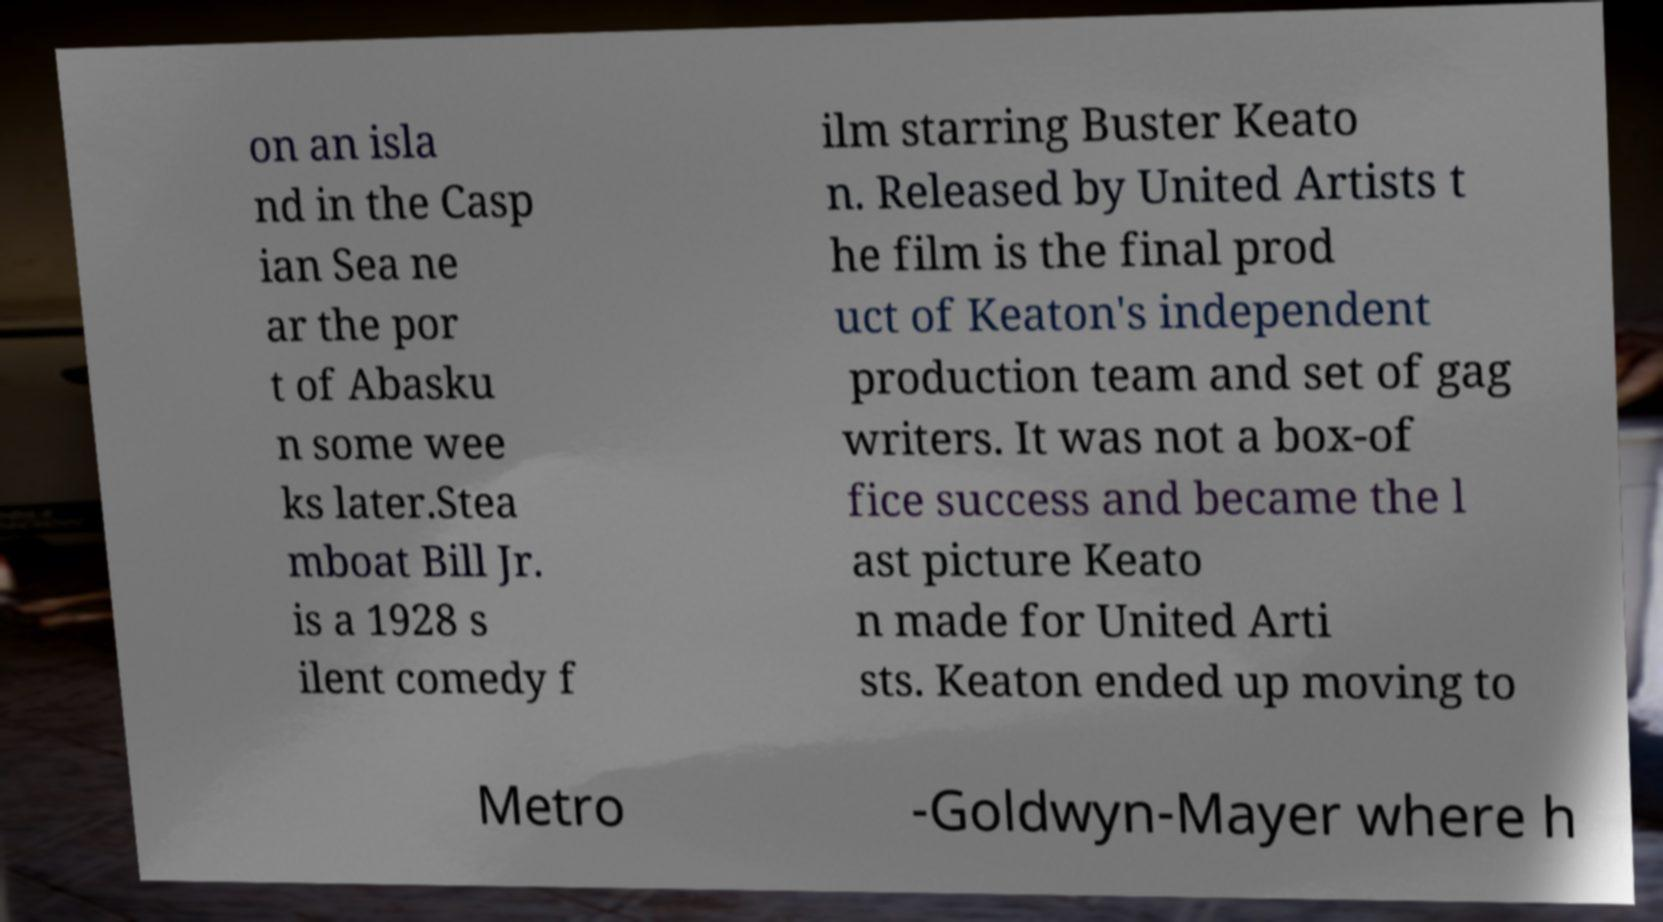For documentation purposes, I need the text within this image transcribed. Could you provide that? on an isla nd in the Casp ian Sea ne ar the por t of Abasku n some wee ks later.Stea mboat Bill Jr. is a 1928 s ilent comedy f ilm starring Buster Keato n. Released by United Artists t he film is the final prod uct of Keaton's independent production team and set of gag writers. It was not a box-of fice success and became the l ast picture Keato n made for United Arti sts. Keaton ended up moving to Metro -Goldwyn-Mayer where h 